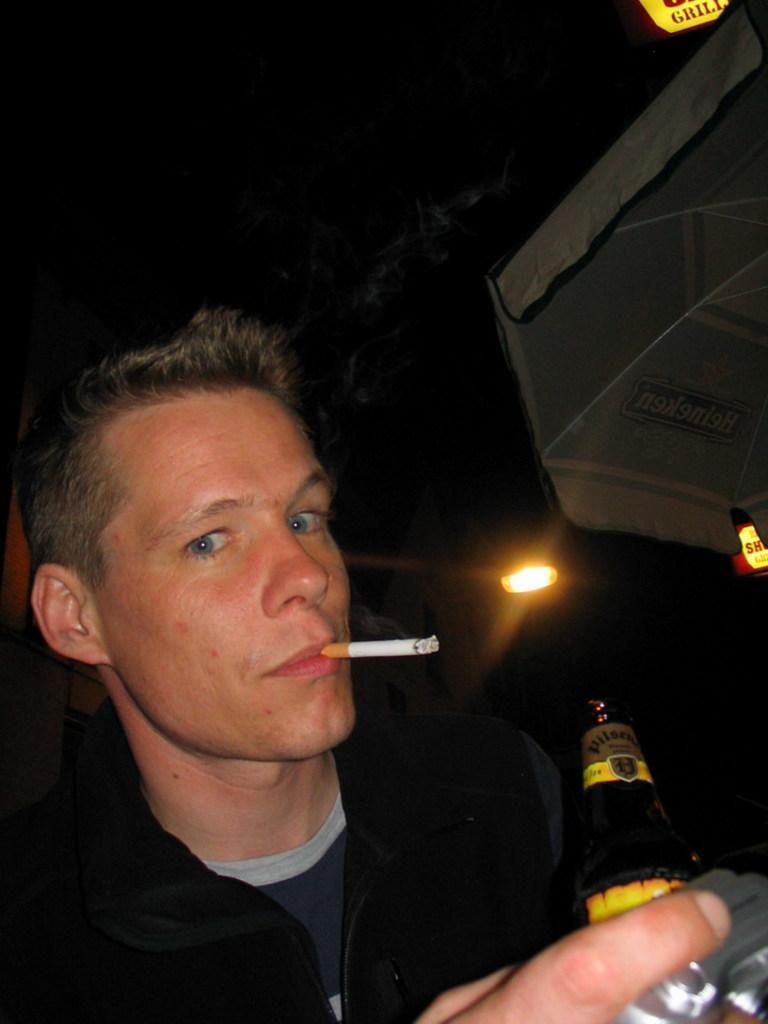How would you summarize this image in a sentence or two? In this image a man is there, who is holding a bottle in his hand and smoking a cigarette who's half visible. The background top is dark in color and but is visible. This image is taken inside a bar. 